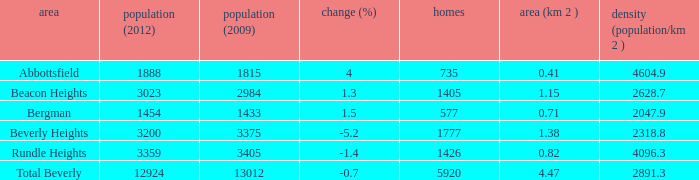What is the density of an area that is 1.38km and has a population more than 12924? 0.0. 